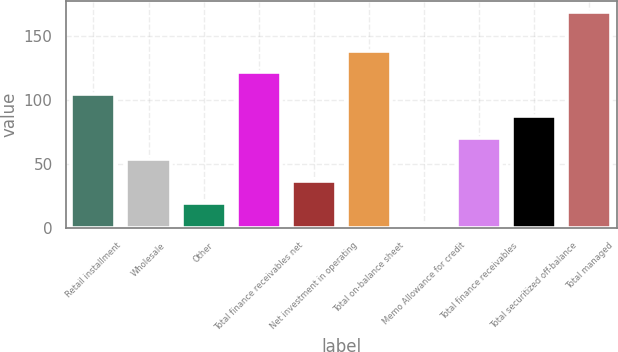<chart> <loc_0><loc_0><loc_500><loc_500><bar_chart><fcel>Retail installment<fcel>Wholesale<fcel>Other<fcel>Total finance receivables net<fcel>Net investment in operating<fcel>Total on-balance sheet<fcel>Memo Allowance for credit<fcel>Total finance receivables<fcel>Total securitized off-balance<fcel>Total managed<nl><fcel>104.34<fcel>53.37<fcel>19.39<fcel>121.33<fcel>36.38<fcel>138.32<fcel>2.4<fcel>70.36<fcel>87.35<fcel>168.3<nl></chart> 